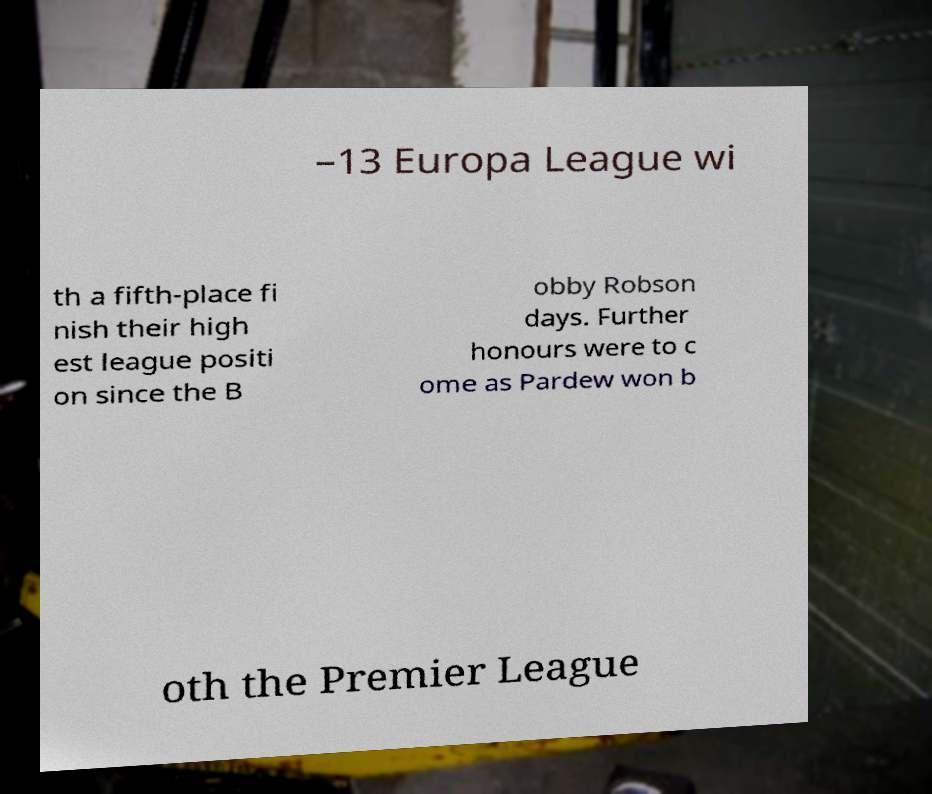Please identify and transcribe the text found in this image. –13 Europa League wi th a fifth-place fi nish their high est league positi on since the B obby Robson days. Further honours were to c ome as Pardew won b oth the Premier League 